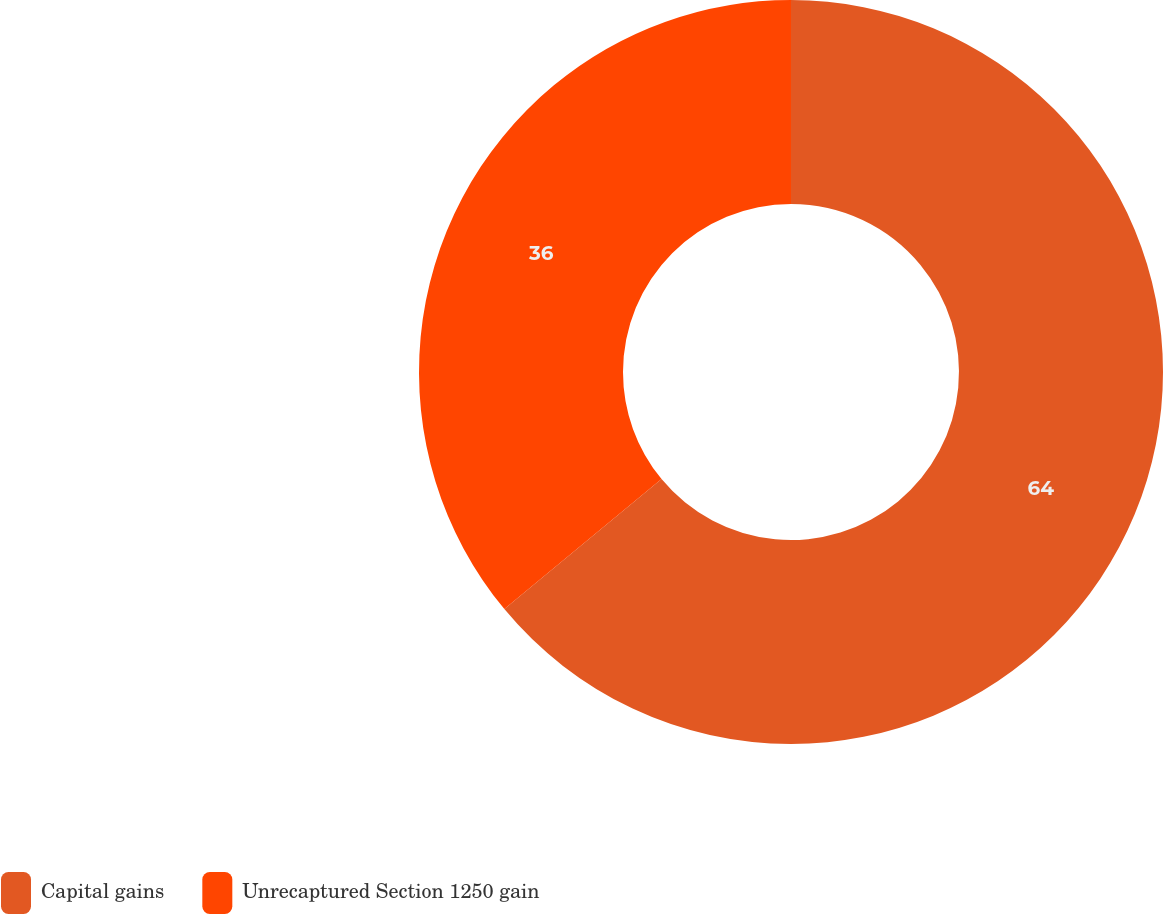Convert chart. <chart><loc_0><loc_0><loc_500><loc_500><pie_chart><fcel>Capital gains<fcel>Unrecaptured Section 1250 gain<nl><fcel>64.0%<fcel>36.0%<nl></chart> 